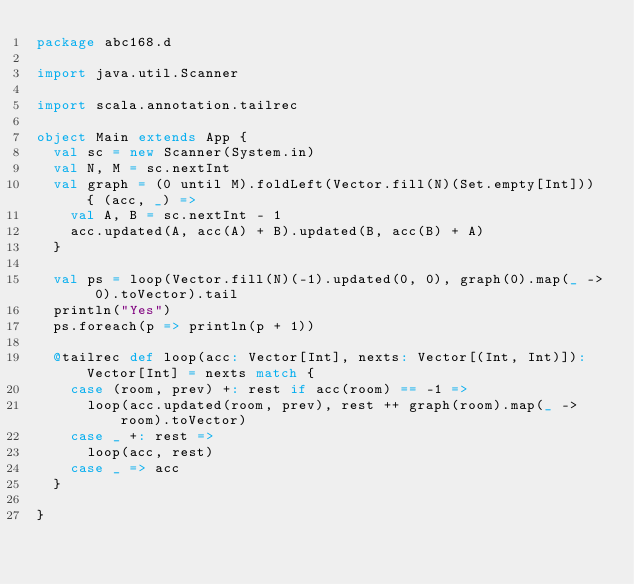<code> <loc_0><loc_0><loc_500><loc_500><_Scala_>package abc168.d

import java.util.Scanner

import scala.annotation.tailrec

object Main extends App {
  val sc = new Scanner(System.in)
  val N, M = sc.nextInt
  val graph = (0 until M).foldLeft(Vector.fill(N)(Set.empty[Int])) { (acc, _) =>
    val A, B = sc.nextInt - 1
    acc.updated(A, acc(A) + B).updated(B, acc(B) + A)
  }

  val ps = loop(Vector.fill(N)(-1).updated(0, 0), graph(0).map(_ -> 0).toVector).tail
  println("Yes")
  ps.foreach(p => println(p + 1))

  @tailrec def loop(acc: Vector[Int], nexts: Vector[(Int, Int)]): Vector[Int] = nexts match {
    case (room, prev) +: rest if acc(room) == -1 =>
      loop(acc.updated(room, prev), rest ++ graph(room).map(_ -> room).toVector)
    case _ +: rest =>
      loop(acc, rest)
    case _ => acc
  }

}

</code> 